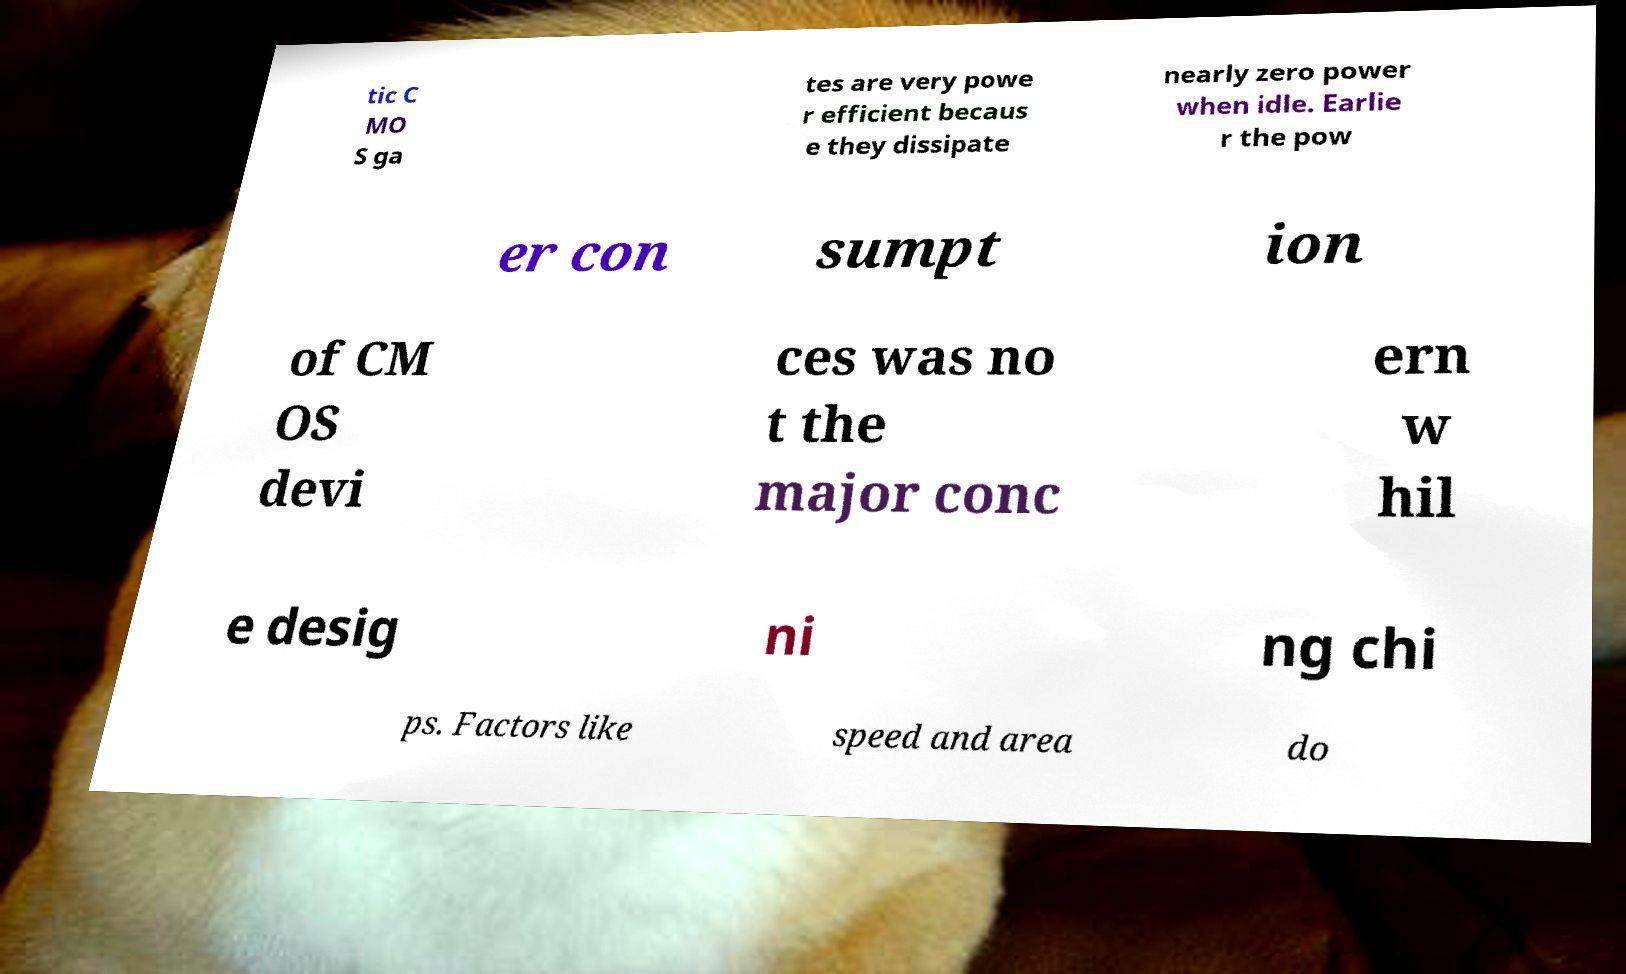Please read and relay the text visible in this image. What does it say? tic C MO S ga tes are very powe r efficient becaus e they dissipate nearly zero power when idle. Earlie r the pow er con sumpt ion of CM OS devi ces was no t the major conc ern w hil e desig ni ng chi ps. Factors like speed and area do 